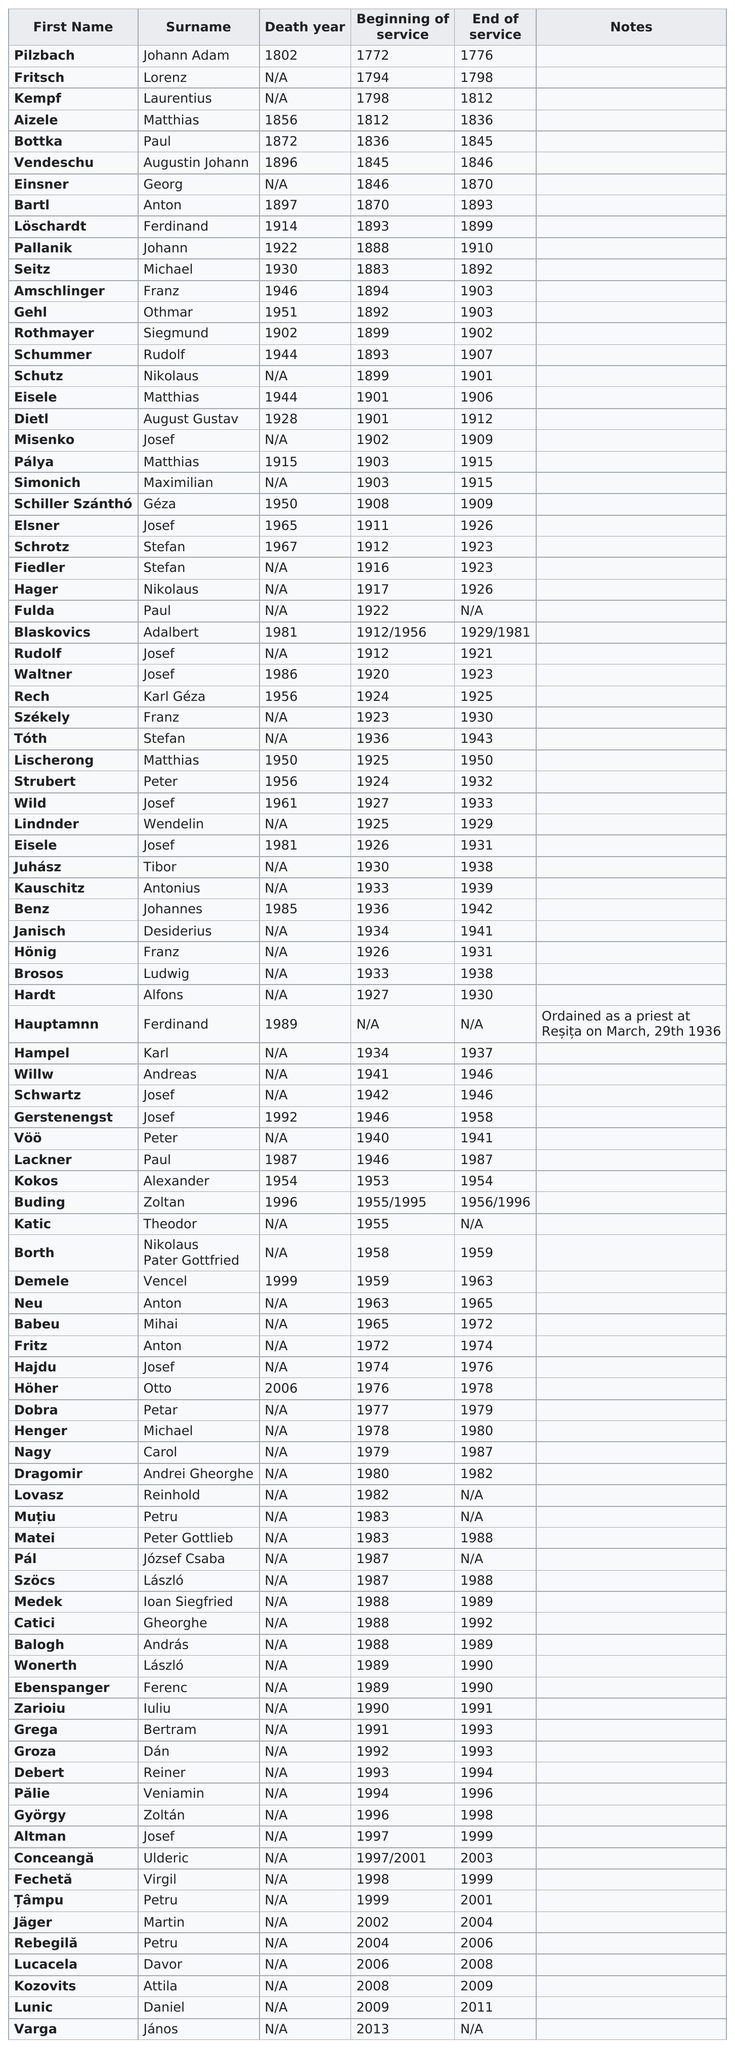Mention a couple of crucial points in this snapshot. The difference between the year Seitz died and the year Aizele died is 74 years. Pilzbach's period of service lasted for a total of 4 years. What is the first name that comes before Kempf? Fritsch. After 1900, there were 82 priests who ended their service. It is estimated that 84 priests did not begin their service until after 1880. 